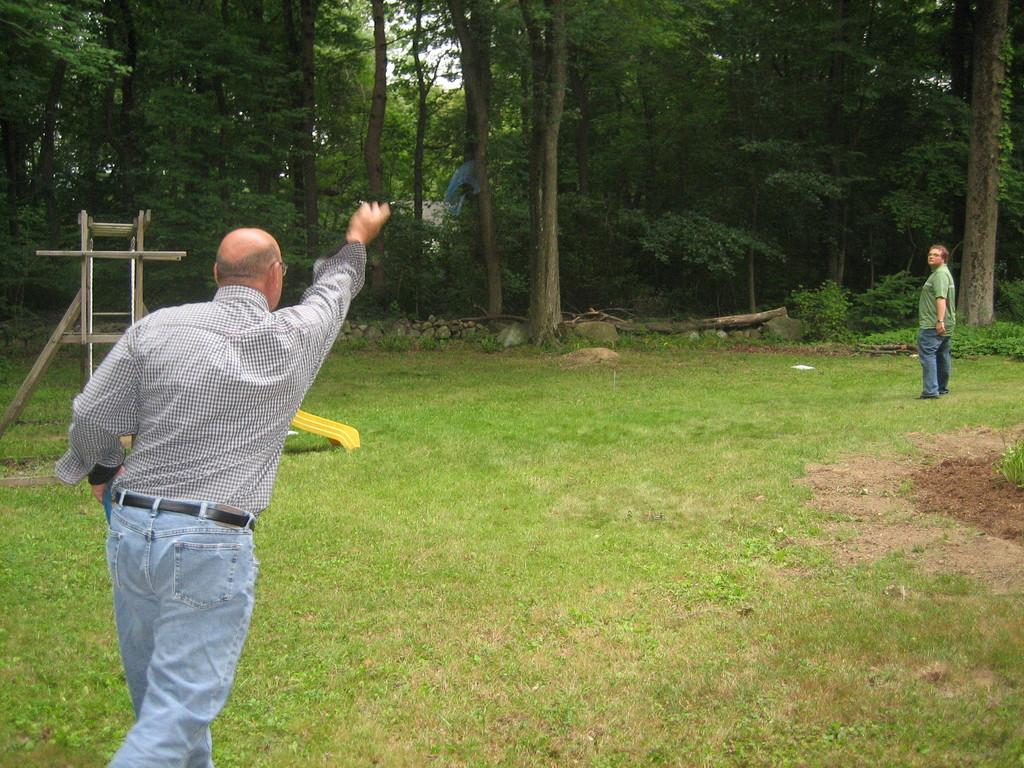How many people are in the image? There are two people standing in the image. What can be seen in the background of the image? A wooden slide, grass, tree trunks, trees, and the sky are visible in the image. What type of surface is the wooden slide on? The wooden slide is on grass, as grass is visible in the image. What shape is the square made of sticks in the image? There is no square made of sticks present in the image. How do the people in the image say good-bye to each other? The image does not show the people interacting or saying good-bye to each other. 